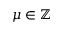<formula> <loc_0><loc_0><loc_500><loc_500>\mu \in \mathbb { Z }</formula> 